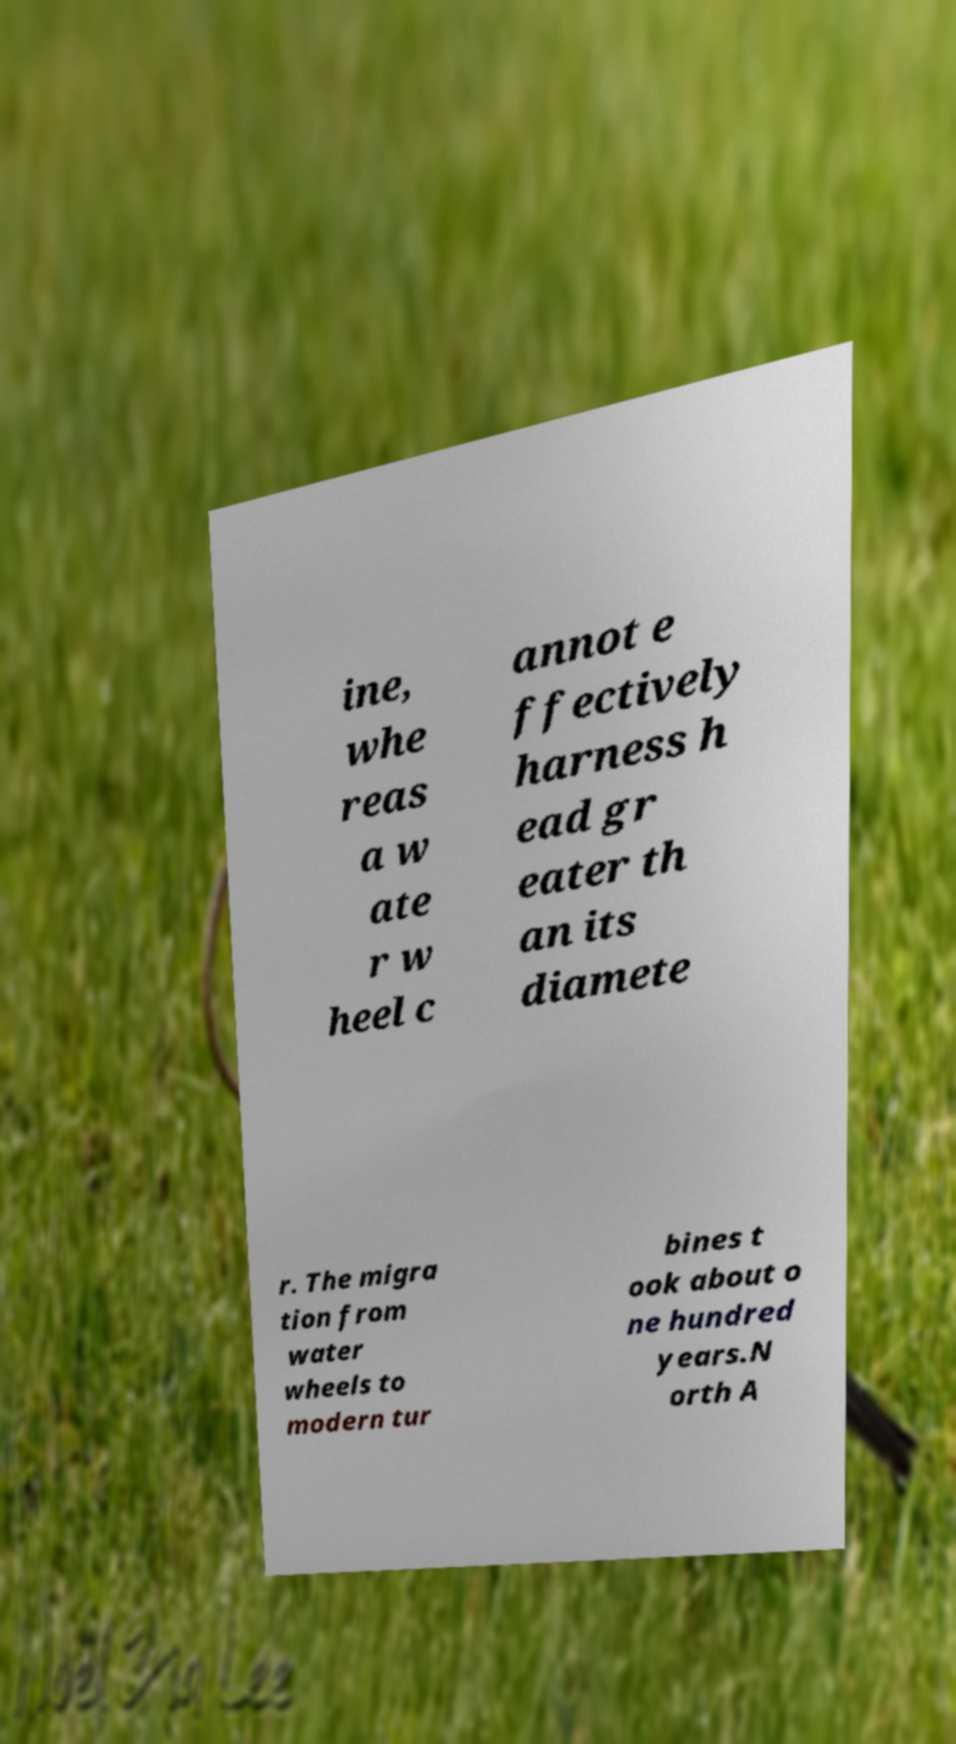Please identify and transcribe the text found in this image. ine, whe reas a w ate r w heel c annot e ffectively harness h ead gr eater th an its diamete r. The migra tion from water wheels to modern tur bines t ook about o ne hundred years.N orth A 